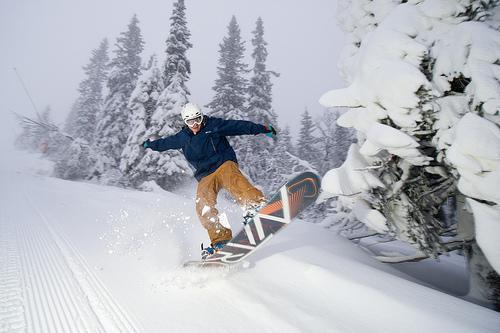How many snowboarders?
Give a very brief answer. 1. How many people are pictured?
Give a very brief answer. 1. How many people are there?
Give a very brief answer. 1. 